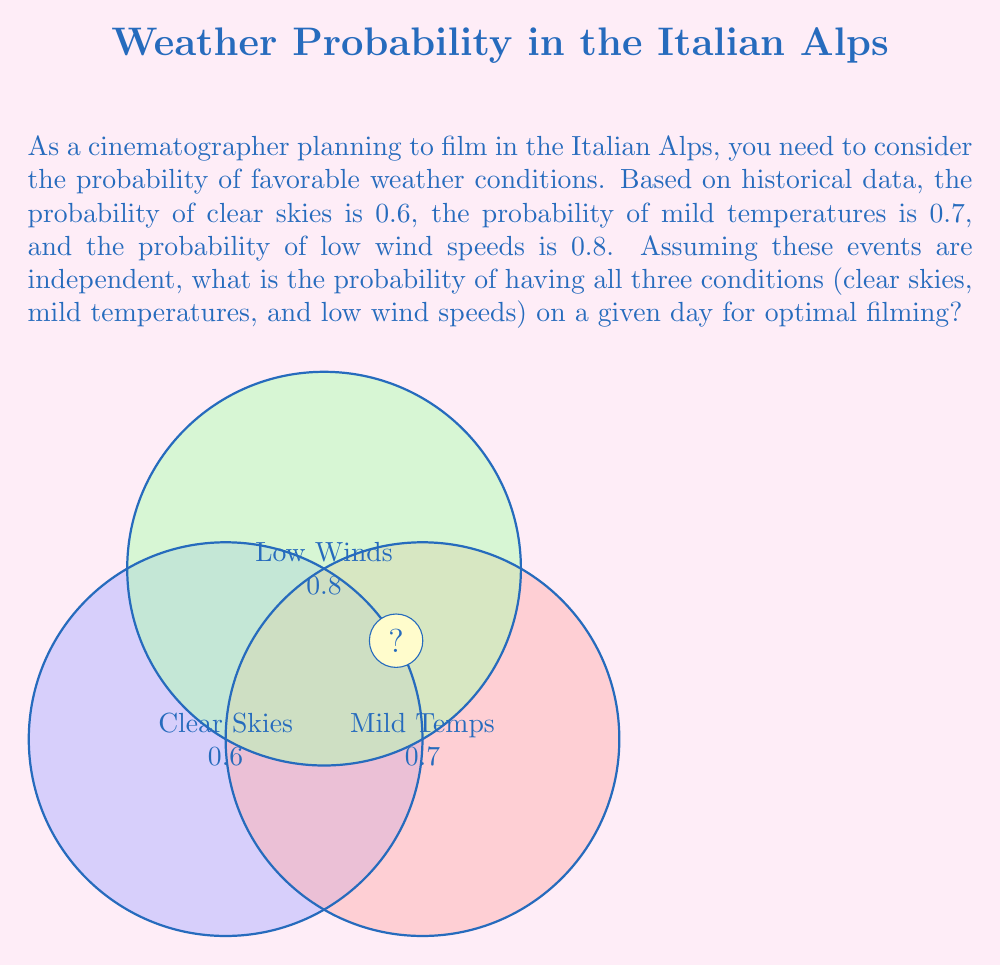Could you help me with this problem? To solve this problem, we need to use the multiplication rule for independent events. The probability of all three events occurring simultaneously is the product of their individual probabilities.

Let's define our events:
A: Clear skies (P(A) = 0.6)
B: Mild temperatures (P(B) = 0.7)
C: Low wind speeds (P(C) = 0.8)

We want to find P(A ∩ B ∩ C), the probability of all three events occurring together.

Since the events are independent:

P(A ∩ B ∩ C) = P(A) × P(B) × P(C)

Substituting the given probabilities:

$$ P(A ∩ B ∩ C) = 0.6 × 0.7 × 0.8 $$

Calculating:

$$ P(A ∩ B ∩ C) = 0.336 $$

Therefore, the probability of having all three favorable conditions on a given day is 0.336 or 33.6%.
Answer: 0.336 